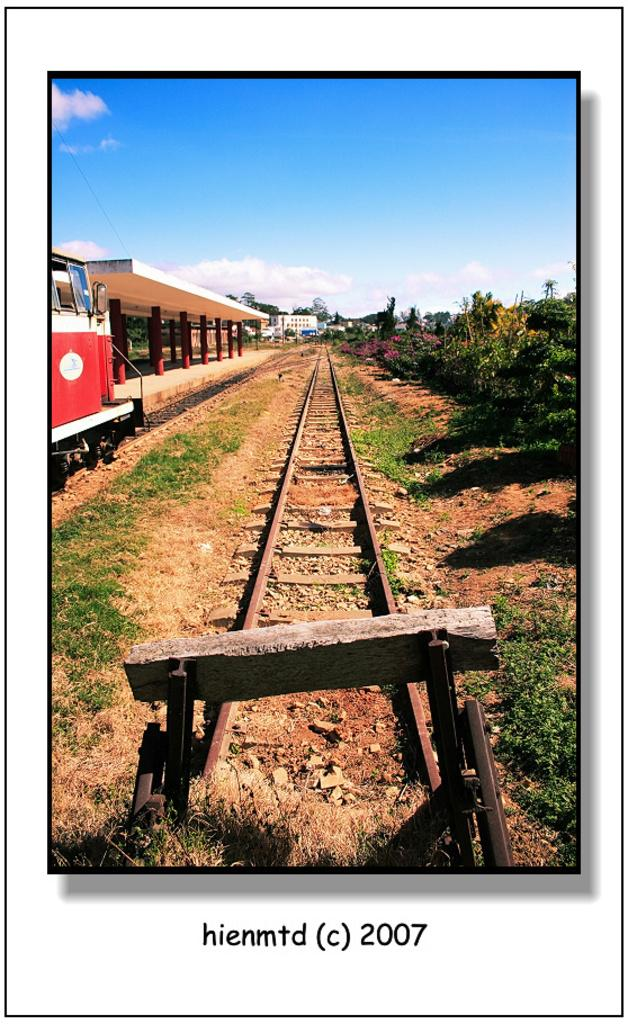<image>
Write a terse but informative summary of the picture. a card that has the numbers 2007 on it 